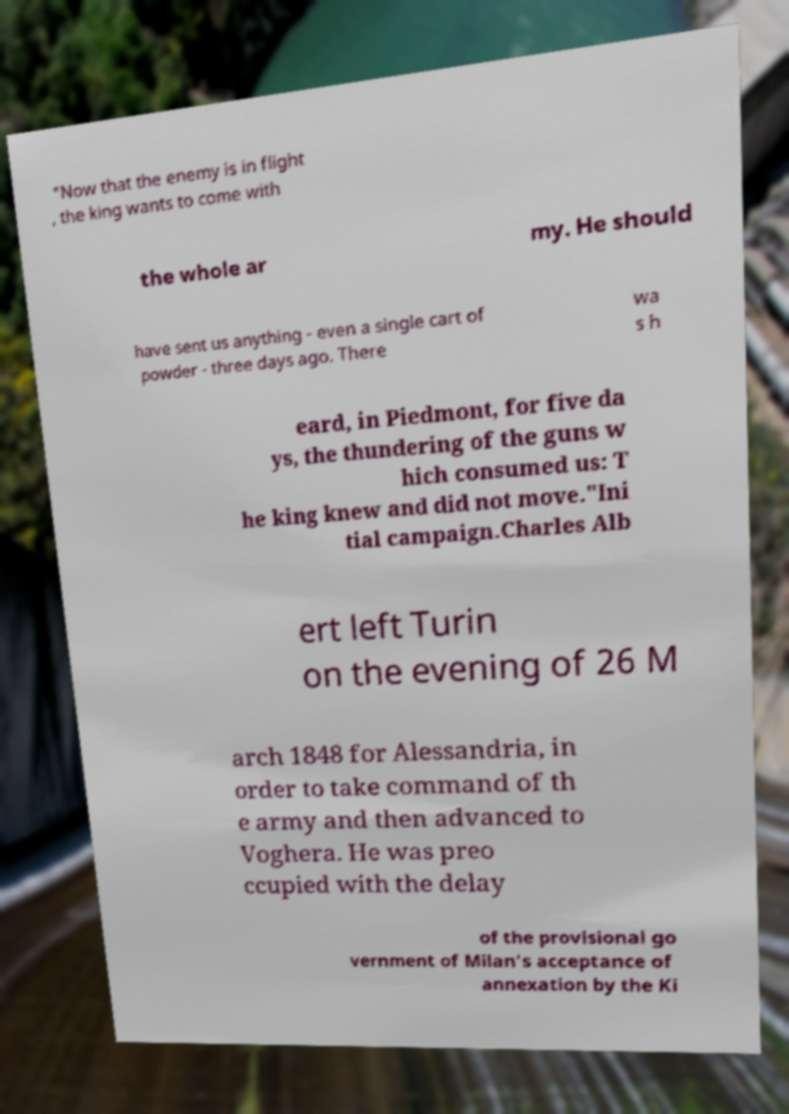For documentation purposes, I need the text within this image transcribed. Could you provide that? "Now that the enemy is in flight , the king wants to come with the whole ar my. He should have sent us anything - even a single cart of powder - three days ago. There wa s h eard, in Piedmont, for five da ys, the thundering of the guns w hich consumed us: T he king knew and did not move."Ini tial campaign.Charles Alb ert left Turin on the evening of 26 M arch 1848 for Alessandria, in order to take command of th e army and then advanced to Voghera. He was preo ccupied with the delay of the provisional go vernment of Milan's acceptance of annexation by the Ki 